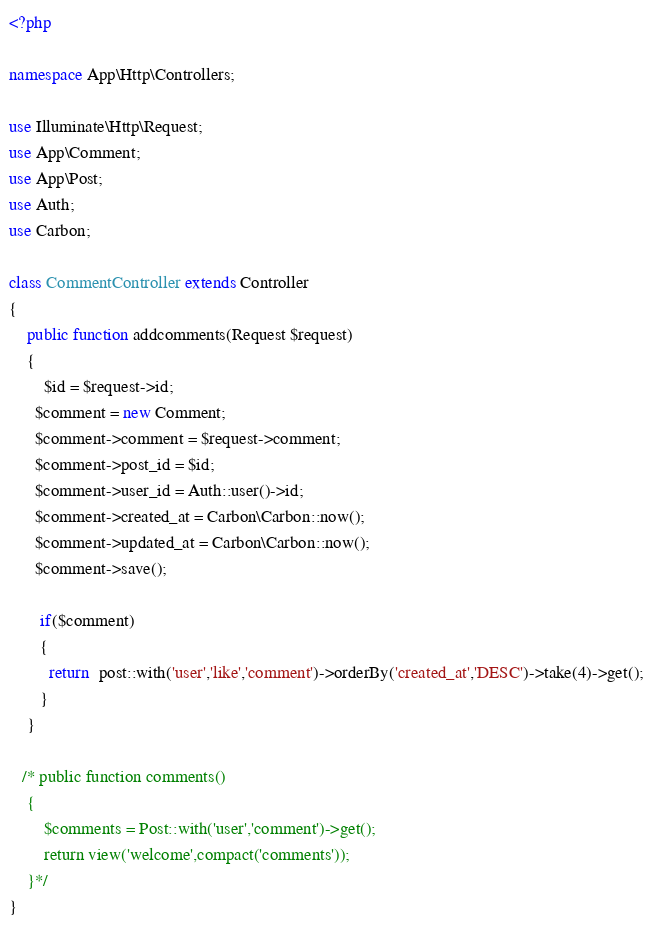Convert code to text. <code><loc_0><loc_0><loc_500><loc_500><_PHP_><?php

namespace App\Http\Controllers;

use Illuminate\Http\Request;
use App\Comment;
use App\Post;
use Auth;
use Carbon;

class CommentController extends Controller
{
    public function addcomments(Request $request)
    {
    	$id = $request->id;
      $comment = new Comment;
   	  $comment->comment = $request->comment;
   	  $comment->post_id = $id;
      $comment->user_id = Auth::user()->id;
      $comment->created_at = Carbon\Carbon::now();
      $comment->updated_at = Carbon\Carbon::now();
      $comment->save();

       if($comment)
       {
         return  post::with('user','like','comment')->orderBy('created_at','DESC')->take(4)->get();   
       }
    }	

   /* public function comments()
    {
    	$comments = Post::with('user','comment')->get();
    	return view('welcome',compact('comments'));
    }*/
}
</code> 